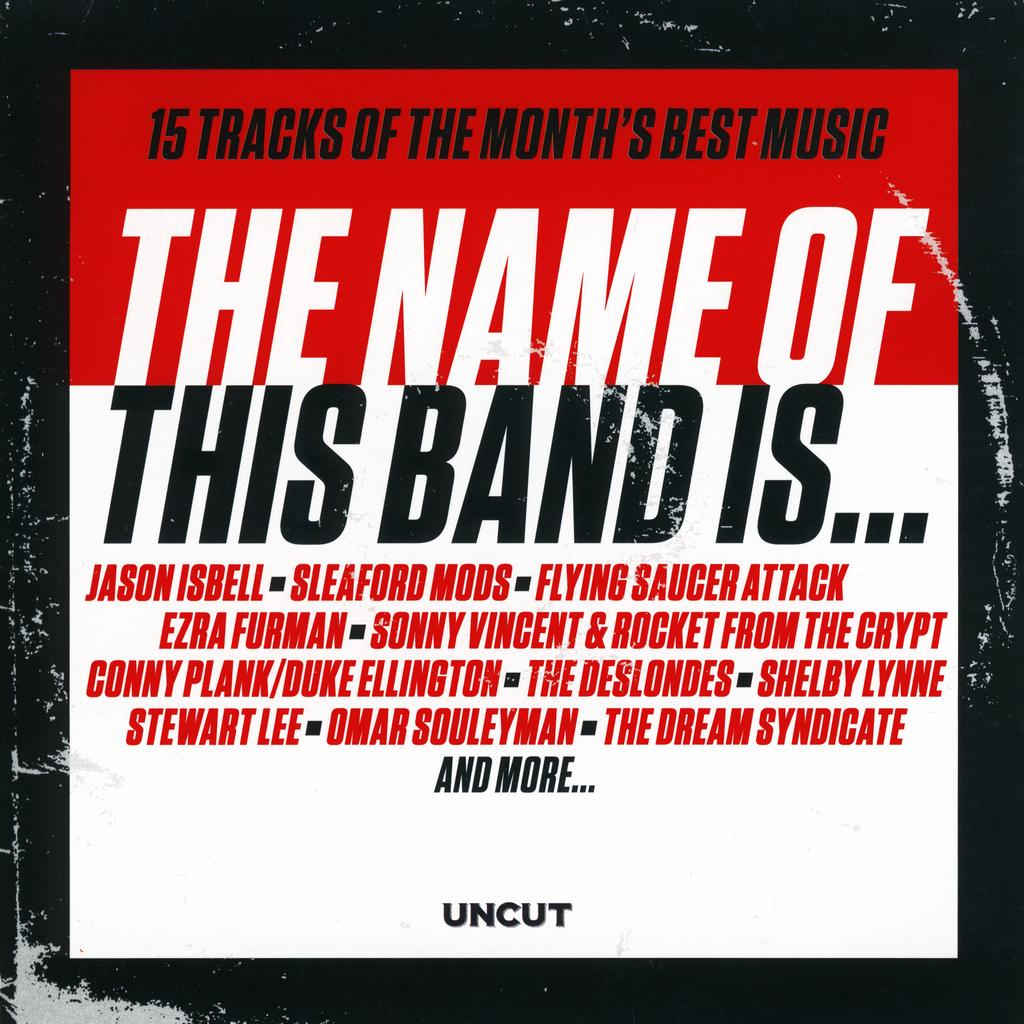<image>
Provide a brief description of the given image. A white and red poster with some black letters that says this band is.... 